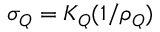<formula> <loc_0><loc_0><loc_500><loc_500>\sigma _ { Q } = K _ { Q } ( 1 / \rho _ { Q } )</formula> 